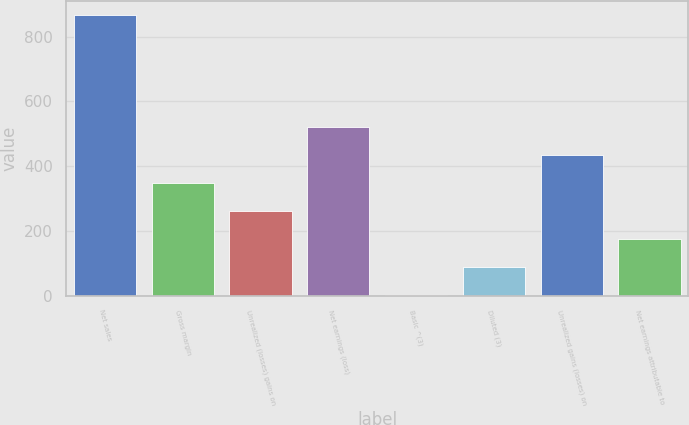<chart> <loc_0><loc_0><loc_500><loc_500><bar_chart><fcel>Net sales<fcel>Gross margin<fcel>Unrealized (losses) gains on<fcel>Net earnings (loss)<fcel>Basic ^(3)<fcel>Diluted (3)<fcel>Unrealized gains (losses) on<fcel>Net earnings attributable to<nl><fcel>867<fcel>347.62<fcel>261.06<fcel>520.74<fcel>1.38<fcel>87.94<fcel>434.18<fcel>174.5<nl></chart> 